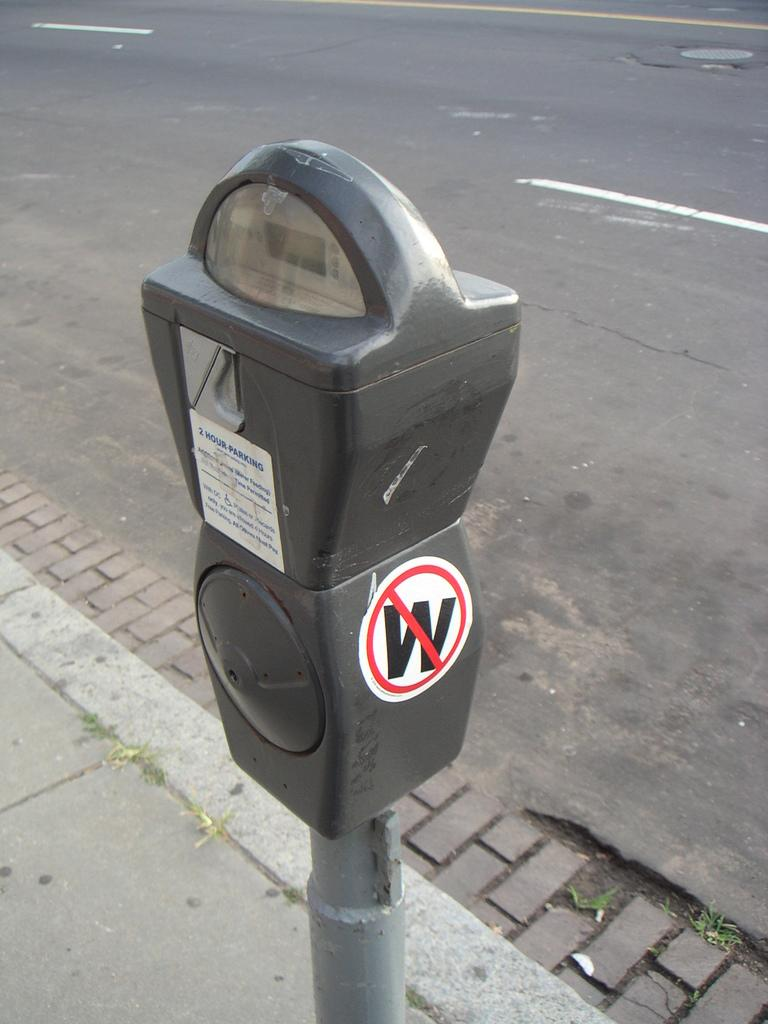What is located in the center of the image? There is a curb in the center of the image. How many fish can be seen swimming in the lake in the image? There is no lake or fish present in the image; it only features a curb. 